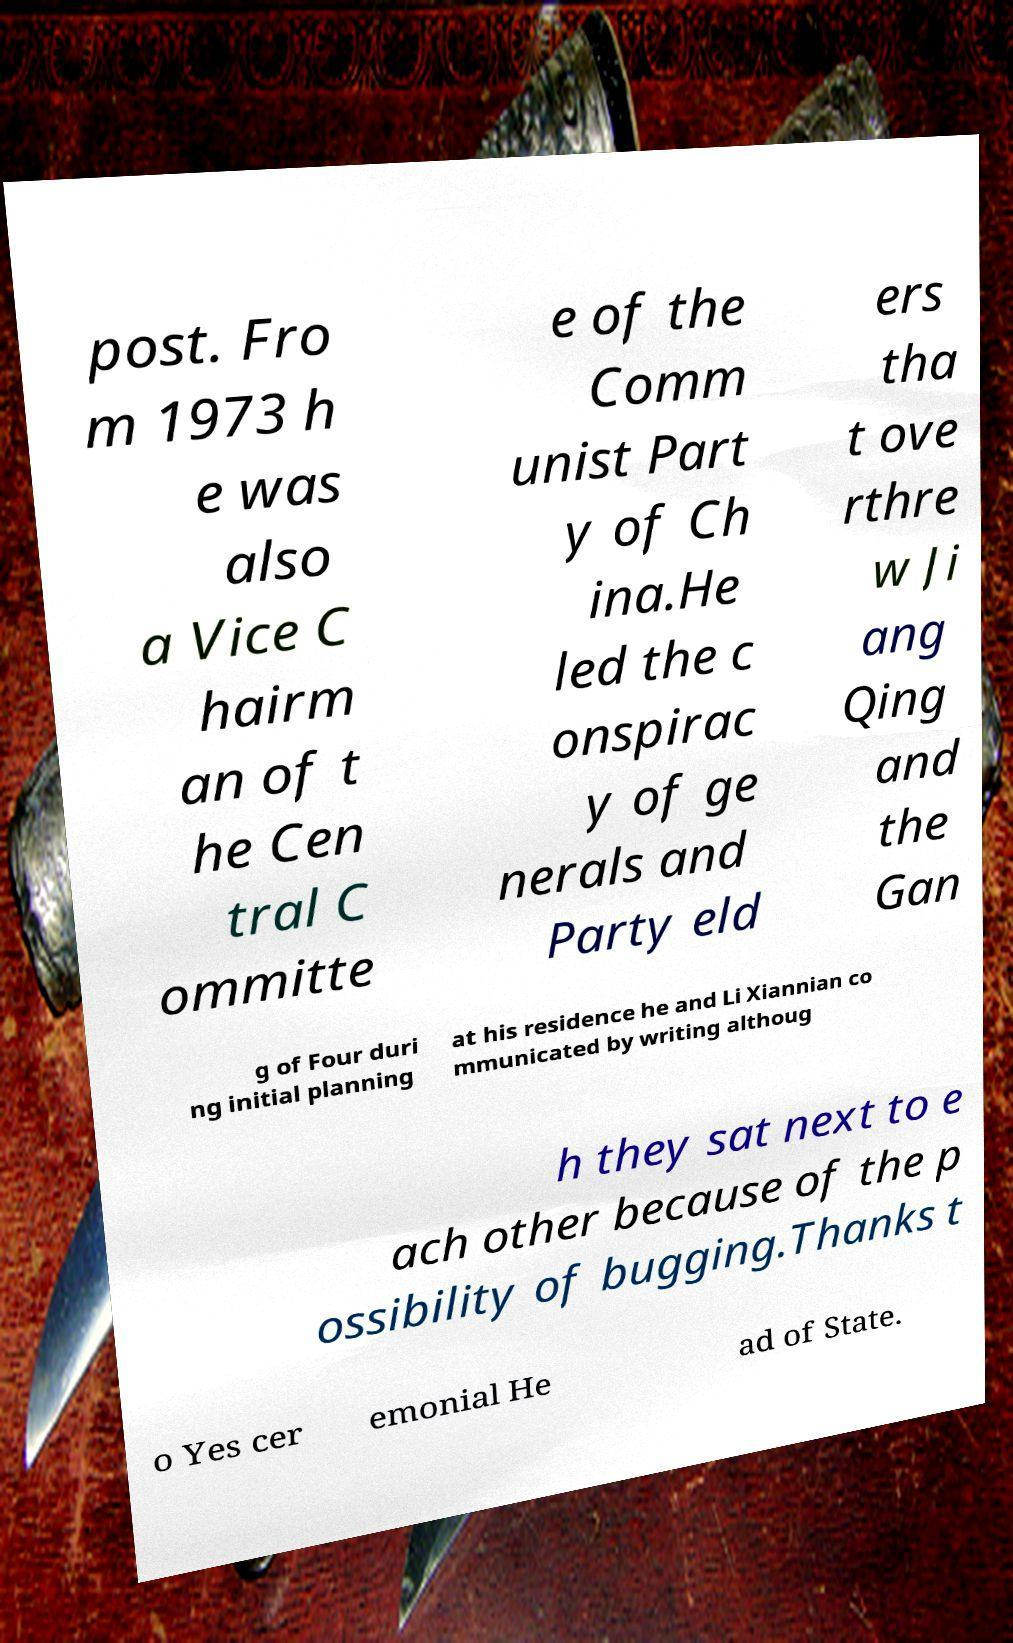Can you read and provide the text displayed in the image?This photo seems to have some interesting text. Can you extract and type it out for me? post. Fro m 1973 h e was also a Vice C hairm an of t he Cen tral C ommitte e of the Comm unist Part y of Ch ina.He led the c onspirac y of ge nerals and Party eld ers tha t ove rthre w Ji ang Qing and the Gan g of Four duri ng initial planning at his residence he and Li Xiannian co mmunicated by writing althoug h they sat next to e ach other because of the p ossibility of bugging.Thanks t o Yes cer emonial He ad of State. 